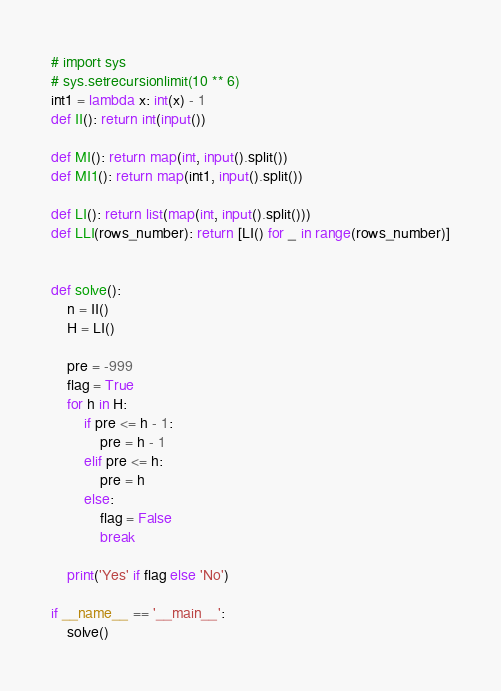Convert code to text. <code><loc_0><loc_0><loc_500><loc_500><_Python_># import sys
# sys.setrecursionlimit(10 ** 6)
int1 = lambda x: int(x) - 1
def II(): return int(input())

def MI(): return map(int, input().split())
def MI1(): return map(int1, input().split())

def LI(): return list(map(int, input().split()))
def LLI(rows_number): return [LI() for _ in range(rows_number)]


def solve():
    n = II()
    H = LI()

    pre = -999
    flag = True
    for h in H:
        if pre <= h - 1:
            pre = h - 1
        elif pre <= h:
            pre = h
        else:
            flag = False
            break

    print('Yes' if flag else 'No')

if __name__ == '__main__':
    solve()
</code> 